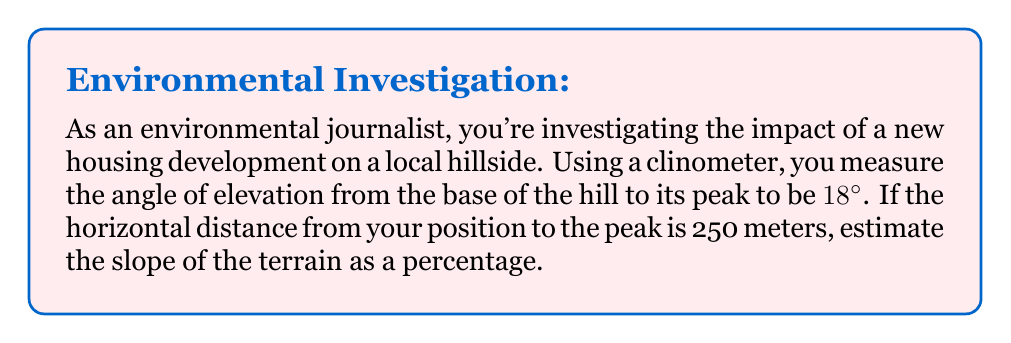Help me with this question. To solve this problem, we'll follow these steps:

1) First, let's recall that slope is typically defined as the ratio of rise (vertical change) to run (horizontal change). In percentage form, it's expressed as:

   $$ \text{Slope (%)} = \frac{\text{Rise}}{\text{Run}} \times 100\% $$

2) In this case, we're given the angle of elevation (18°) and the horizontal distance (250 m). We need to find the vertical rise.

3) This forms a right triangle, where:
   - The hypotenuse is the slope of the hill
   - The adjacent side is the horizontal distance (250 m)
   - The opposite side is the vertical rise we need to find
   - The angle between the horizontal and the slope is 18°

4) To find the vertical rise, we can use the tangent function:

   $$ \tan(\theta) = \frac{\text{Opposite}}{\text{Adjacent}} = \frac{\text{Rise}}{\text{Run}} $$

5) Rearranging this, we get:

   $$ \text{Rise} = \text{Run} \times \tan(\theta) $$

6) Plugging in our values:

   $$ \text{Rise} = 250 \times \tan(18°) \approx 80.51 \text{ meters} $$

7) Now we can calculate the slope as a percentage:

   $$ \text{Slope (%)} = \frac{80.51}{250} \times 100\% \approx 32.20\% $$
Answer: 32.20% 